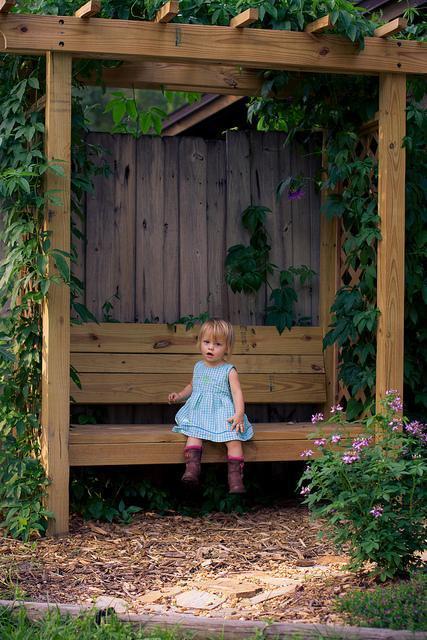How many people are in the picture?
Give a very brief answer. 1. How many dogs?
Give a very brief answer. 0. How many people are sitting on the bench?
Give a very brief answer. 1. 